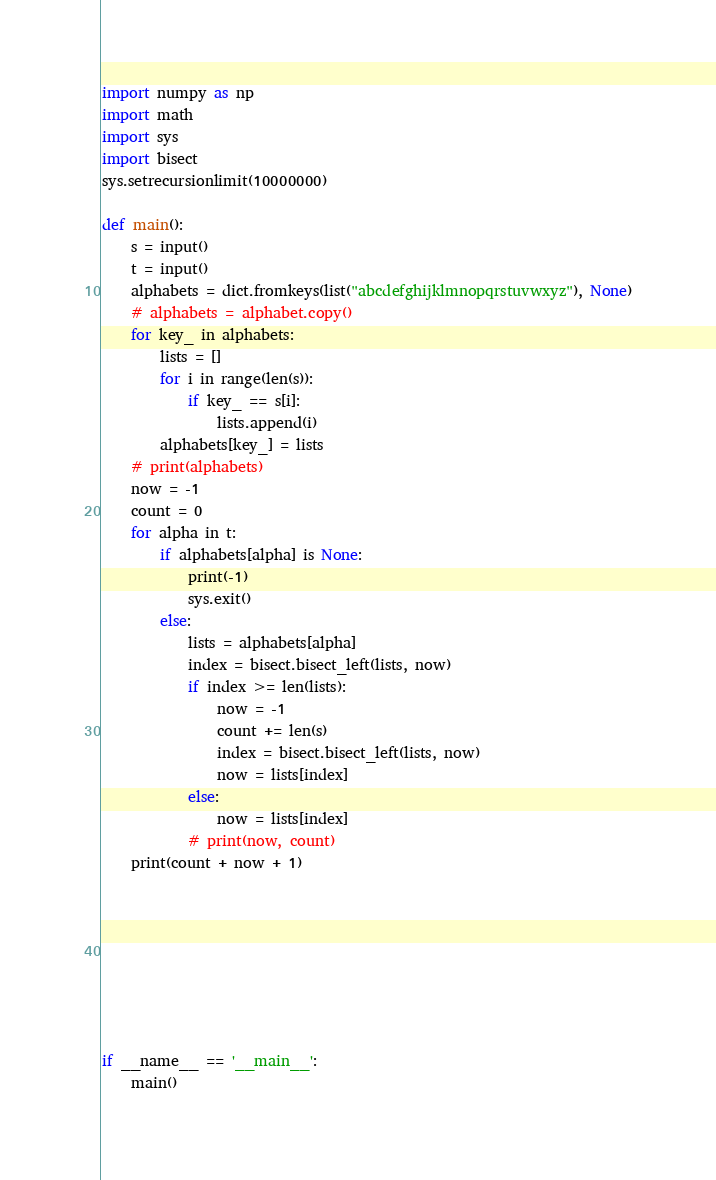<code> <loc_0><loc_0><loc_500><loc_500><_Python_>import numpy as np
import math
import sys
import bisect
sys.setrecursionlimit(10000000)

def main():
    s = input()
    t = input()
    alphabets = dict.fromkeys(list("abcdefghijklmnopqrstuvwxyz"), None)
    # alphabets = alphabet.copy()
    for key_ in alphabets:
        lists = []
        for i in range(len(s)):
            if key_ == s[i]:
                lists.append(i)
        alphabets[key_] = lists
    # print(alphabets)
    now = -1
    count = 0
    for alpha in t:
        if alphabets[alpha] is None:
            print(-1)
            sys.exit()
        else:
            lists = alphabets[alpha]
            index = bisect.bisect_left(lists, now)
            if index >= len(lists):
                now = -1
                count += len(s)
                index = bisect.bisect_left(lists, now)
                now = lists[index]
            else:
                now = lists[index]
            # print(now, count)
    print(count + now + 1)
            







if __name__ == '__main__':
    main()</code> 